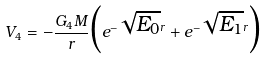<formula> <loc_0><loc_0><loc_500><loc_500>V _ { 4 } = - \frac { G _ { 4 } M } { r } \Big { ( } e ^ { - \sqrt { E _ { 0 } } r } + e ^ { - \sqrt { E _ { 1 } } r } \Big { ) }</formula> 